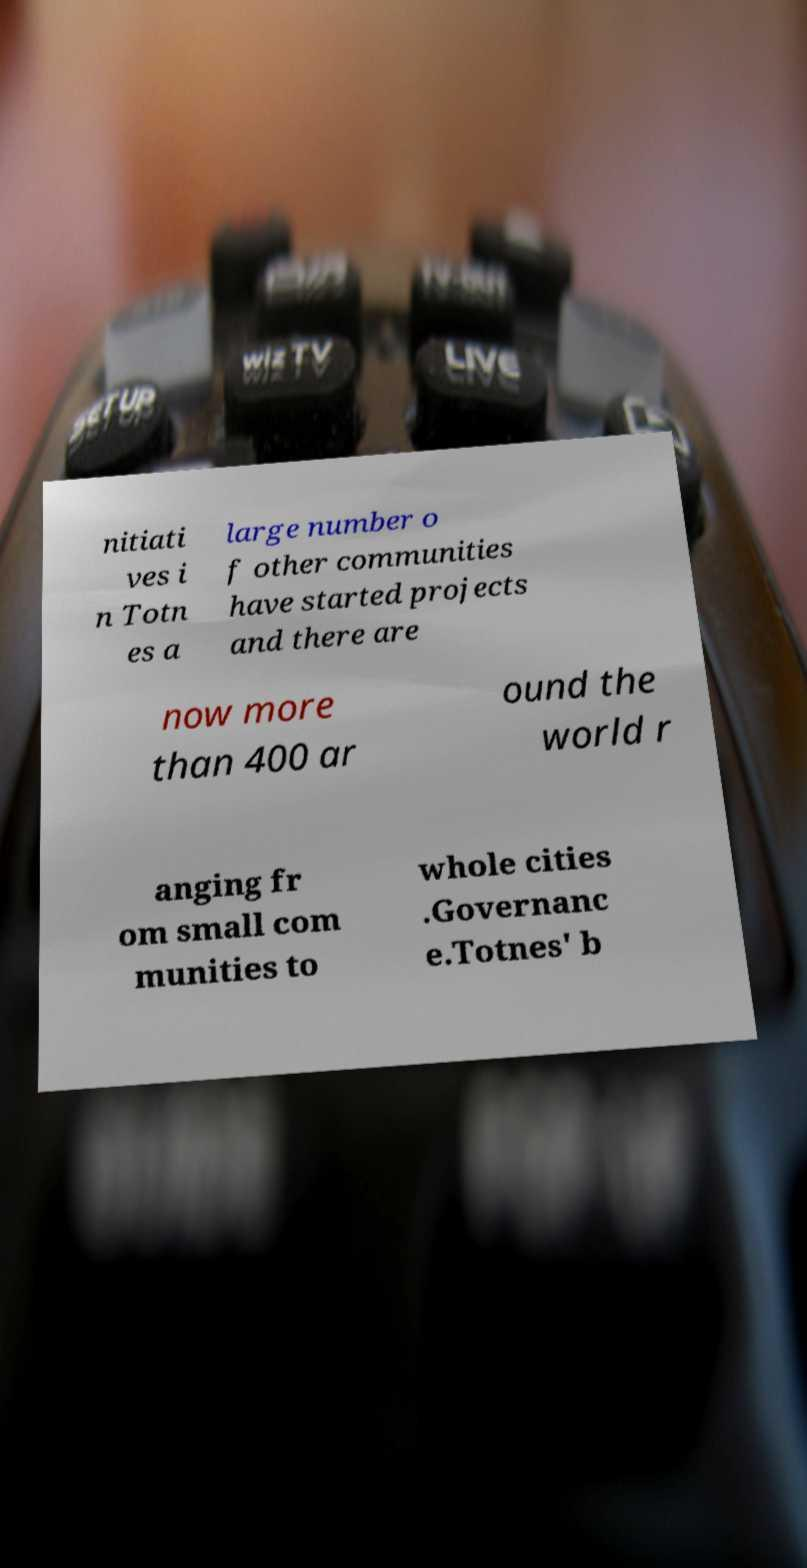For documentation purposes, I need the text within this image transcribed. Could you provide that? nitiati ves i n Totn es a large number o f other communities have started projects and there are now more than 400 ar ound the world r anging fr om small com munities to whole cities .Governanc e.Totnes' b 